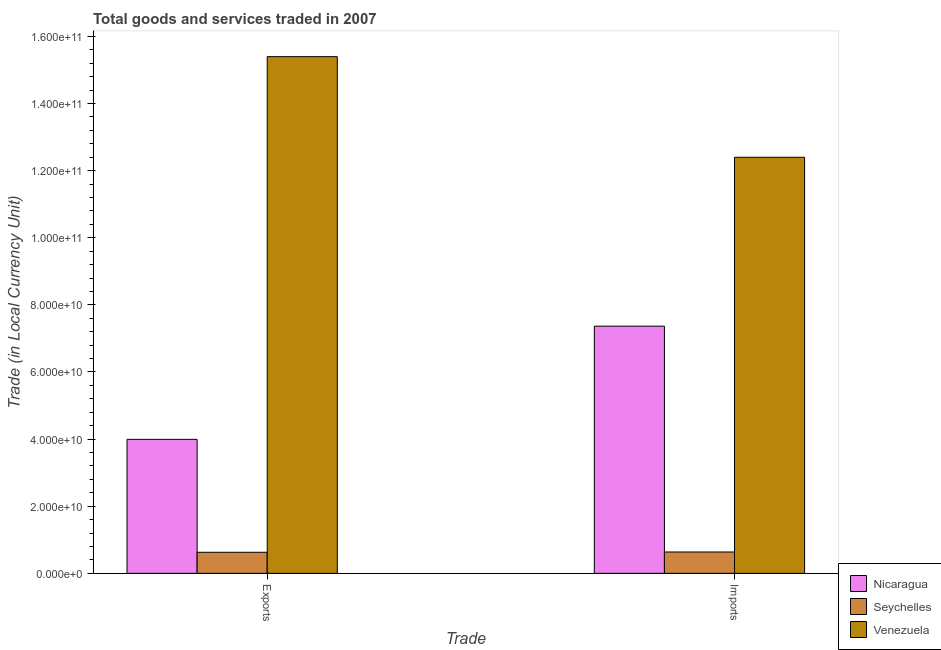How many different coloured bars are there?
Ensure brevity in your answer.  3. Are the number of bars per tick equal to the number of legend labels?
Provide a short and direct response. Yes. How many bars are there on the 1st tick from the left?
Provide a succinct answer. 3. What is the label of the 1st group of bars from the left?
Your response must be concise. Exports. What is the imports of goods and services in Nicaragua?
Ensure brevity in your answer.  7.37e+1. Across all countries, what is the maximum export of goods and services?
Offer a very short reply. 1.54e+11. Across all countries, what is the minimum export of goods and services?
Provide a short and direct response. 6.28e+09. In which country was the export of goods and services maximum?
Provide a succinct answer. Venezuela. In which country was the export of goods and services minimum?
Keep it short and to the point. Seychelles. What is the total export of goods and services in the graph?
Give a very brief answer. 2.00e+11. What is the difference between the export of goods and services in Venezuela and that in Seychelles?
Give a very brief answer. 1.48e+11. What is the difference between the imports of goods and services in Nicaragua and the export of goods and services in Venezuela?
Provide a short and direct response. -8.03e+1. What is the average imports of goods and services per country?
Provide a short and direct response. 6.80e+1. What is the difference between the imports of goods and services and export of goods and services in Venezuela?
Make the answer very short. -3.00e+1. What is the ratio of the imports of goods and services in Seychelles to that in Nicaragua?
Offer a very short reply. 0.09. Is the export of goods and services in Nicaragua less than that in Venezuela?
Your answer should be compact. Yes. What does the 3rd bar from the left in Imports represents?
Provide a succinct answer. Venezuela. What does the 1st bar from the right in Imports represents?
Provide a short and direct response. Venezuela. Are the values on the major ticks of Y-axis written in scientific E-notation?
Your answer should be very brief. Yes. Does the graph contain any zero values?
Offer a terse response. No. Does the graph contain grids?
Offer a very short reply. No. Where does the legend appear in the graph?
Provide a succinct answer. Bottom right. How are the legend labels stacked?
Offer a terse response. Vertical. What is the title of the graph?
Your answer should be compact. Total goods and services traded in 2007. What is the label or title of the X-axis?
Make the answer very short. Trade. What is the label or title of the Y-axis?
Your answer should be very brief. Trade (in Local Currency Unit). What is the Trade (in Local Currency Unit) of Nicaragua in Exports?
Ensure brevity in your answer.  3.99e+1. What is the Trade (in Local Currency Unit) in Seychelles in Exports?
Keep it short and to the point. 6.28e+09. What is the Trade (in Local Currency Unit) in Venezuela in Exports?
Give a very brief answer. 1.54e+11. What is the Trade (in Local Currency Unit) of Nicaragua in Imports?
Provide a succinct answer. 7.37e+1. What is the Trade (in Local Currency Unit) in Seychelles in Imports?
Make the answer very short. 6.36e+09. What is the Trade (in Local Currency Unit) in Venezuela in Imports?
Your answer should be very brief. 1.24e+11. Across all Trade, what is the maximum Trade (in Local Currency Unit) in Nicaragua?
Provide a short and direct response. 7.37e+1. Across all Trade, what is the maximum Trade (in Local Currency Unit) of Seychelles?
Your response must be concise. 6.36e+09. Across all Trade, what is the maximum Trade (in Local Currency Unit) of Venezuela?
Offer a very short reply. 1.54e+11. Across all Trade, what is the minimum Trade (in Local Currency Unit) of Nicaragua?
Make the answer very short. 3.99e+1. Across all Trade, what is the minimum Trade (in Local Currency Unit) in Seychelles?
Provide a succinct answer. 6.28e+09. Across all Trade, what is the minimum Trade (in Local Currency Unit) of Venezuela?
Make the answer very short. 1.24e+11. What is the total Trade (in Local Currency Unit) of Nicaragua in the graph?
Your response must be concise. 1.14e+11. What is the total Trade (in Local Currency Unit) in Seychelles in the graph?
Ensure brevity in your answer.  1.26e+1. What is the total Trade (in Local Currency Unit) in Venezuela in the graph?
Your answer should be compact. 2.78e+11. What is the difference between the Trade (in Local Currency Unit) of Nicaragua in Exports and that in Imports?
Your answer should be compact. -3.37e+1. What is the difference between the Trade (in Local Currency Unit) in Seychelles in Exports and that in Imports?
Your answer should be very brief. -8.22e+07. What is the difference between the Trade (in Local Currency Unit) in Venezuela in Exports and that in Imports?
Give a very brief answer. 3.00e+1. What is the difference between the Trade (in Local Currency Unit) in Nicaragua in Exports and the Trade (in Local Currency Unit) in Seychelles in Imports?
Make the answer very short. 3.36e+1. What is the difference between the Trade (in Local Currency Unit) in Nicaragua in Exports and the Trade (in Local Currency Unit) in Venezuela in Imports?
Provide a short and direct response. -8.41e+1. What is the difference between the Trade (in Local Currency Unit) of Seychelles in Exports and the Trade (in Local Currency Unit) of Venezuela in Imports?
Offer a terse response. -1.18e+11. What is the average Trade (in Local Currency Unit) of Nicaragua per Trade?
Your response must be concise. 5.68e+1. What is the average Trade (in Local Currency Unit) of Seychelles per Trade?
Provide a succinct answer. 6.32e+09. What is the average Trade (in Local Currency Unit) of Venezuela per Trade?
Keep it short and to the point. 1.39e+11. What is the difference between the Trade (in Local Currency Unit) of Nicaragua and Trade (in Local Currency Unit) of Seychelles in Exports?
Keep it short and to the point. 3.37e+1. What is the difference between the Trade (in Local Currency Unit) in Nicaragua and Trade (in Local Currency Unit) in Venezuela in Exports?
Keep it short and to the point. -1.14e+11. What is the difference between the Trade (in Local Currency Unit) in Seychelles and Trade (in Local Currency Unit) in Venezuela in Exports?
Offer a terse response. -1.48e+11. What is the difference between the Trade (in Local Currency Unit) of Nicaragua and Trade (in Local Currency Unit) of Seychelles in Imports?
Offer a very short reply. 6.73e+1. What is the difference between the Trade (in Local Currency Unit) in Nicaragua and Trade (in Local Currency Unit) in Venezuela in Imports?
Offer a very short reply. -5.03e+1. What is the difference between the Trade (in Local Currency Unit) of Seychelles and Trade (in Local Currency Unit) of Venezuela in Imports?
Your response must be concise. -1.18e+11. What is the ratio of the Trade (in Local Currency Unit) of Nicaragua in Exports to that in Imports?
Your answer should be compact. 0.54. What is the ratio of the Trade (in Local Currency Unit) of Seychelles in Exports to that in Imports?
Provide a short and direct response. 0.99. What is the ratio of the Trade (in Local Currency Unit) of Venezuela in Exports to that in Imports?
Provide a succinct answer. 1.24. What is the difference between the highest and the second highest Trade (in Local Currency Unit) of Nicaragua?
Ensure brevity in your answer.  3.37e+1. What is the difference between the highest and the second highest Trade (in Local Currency Unit) in Seychelles?
Make the answer very short. 8.22e+07. What is the difference between the highest and the second highest Trade (in Local Currency Unit) in Venezuela?
Ensure brevity in your answer.  3.00e+1. What is the difference between the highest and the lowest Trade (in Local Currency Unit) in Nicaragua?
Provide a short and direct response. 3.37e+1. What is the difference between the highest and the lowest Trade (in Local Currency Unit) in Seychelles?
Keep it short and to the point. 8.22e+07. What is the difference between the highest and the lowest Trade (in Local Currency Unit) in Venezuela?
Keep it short and to the point. 3.00e+1. 